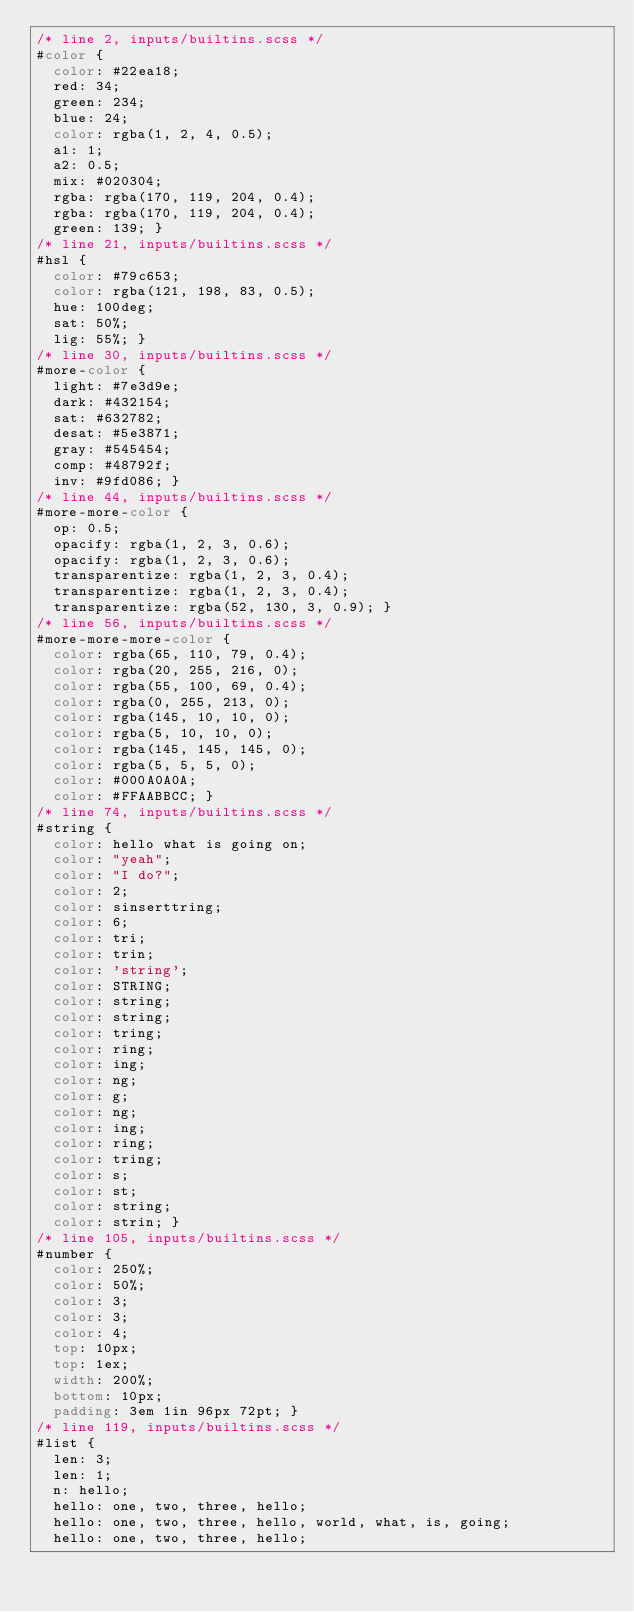<code> <loc_0><loc_0><loc_500><loc_500><_CSS_>/* line 2, inputs/builtins.scss */
#color {
  color: #22ea18;
  red: 34;
  green: 234;
  blue: 24;
  color: rgba(1, 2, 4, 0.5);
  a1: 1;
  a2: 0.5;
  mix: #020304;
  rgba: rgba(170, 119, 204, 0.4);
  rgba: rgba(170, 119, 204, 0.4);
  green: 139; }
/* line 21, inputs/builtins.scss */
#hsl {
  color: #79c653;
  color: rgba(121, 198, 83, 0.5);
  hue: 100deg;
  sat: 50%;
  lig: 55%; }
/* line 30, inputs/builtins.scss */
#more-color {
  light: #7e3d9e;
  dark: #432154;
  sat: #632782;
  desat: #5e3871;
  gray: #545454;
  comp: #48792f;
  inv: #9fd086; }
/* line 44, inputs/builtins.scss */
#more-more-color {
  op: 0.5;
  opacify: rgba(1, 2, 3, 0.6);
  opacify: rgba(1, 2, 3, 0.6);
  transparentize: rgba(1, 2, 3, 0.4);
  transparentize: rgba(1, 2, 3, 0.4);
  transparentize: rgba(52, 130, 3, 0.9); }
/* line 56, inputs/builtins.scss */
#more-more-more-color {
  color: rgba(65, 110, 79, 0.4);
  color: rgba(20, 255, 216, 0);
  color: rgba(55, 100, 69, 0.4);
  color: rgba(0, 255, 213, 0);
  color: rgba(145, 10, 10, 0);
  color: rgba(5, 10, 10, 0);
  color: rgba(145, 145, 145, 0);
  color: rgba(5, 5, 5, 0);
  color: #000A0A0A;
  color: #FFAABBCC; }
/* line 74, inputs/builtins.scss */
#string {
  color: hello what is going on;
  color: "yeah";
  color: "I do?";
  color: 2;
  color: sinserttring;
  color: 6;
  color: tri;
  color: trin;
  color: 'string';
  color: STRING;
  color: string;
  color: string;
  color: tring;
  color: ring;
  color: ing;
  color: ng;
  color: g;
  color: ng;
  color: ing;
  color: ring;
  color: tring;
  color: s;
  color: st;
  color: string;
  color: strin; }
/* line 105, inputs/builtins.scss */
#number {
  color: 250%;
  color: 50%;
  color: 3;
  color: 3;
  color: 4;
  top: 10px;
  top: 1ex;
  width: 200%;
  bottom: 10px;
  padding: 3em 1in 96px 72pt; }
/* line 119, inputs/builtins.scss */
#list {
  len: 3;
  len: 1;
  n: hello;
  hello: one, two, three, hello;
  hello: one, two, three, hello, world, what, is, going;
  hello: one, two, three, hello;</code> 